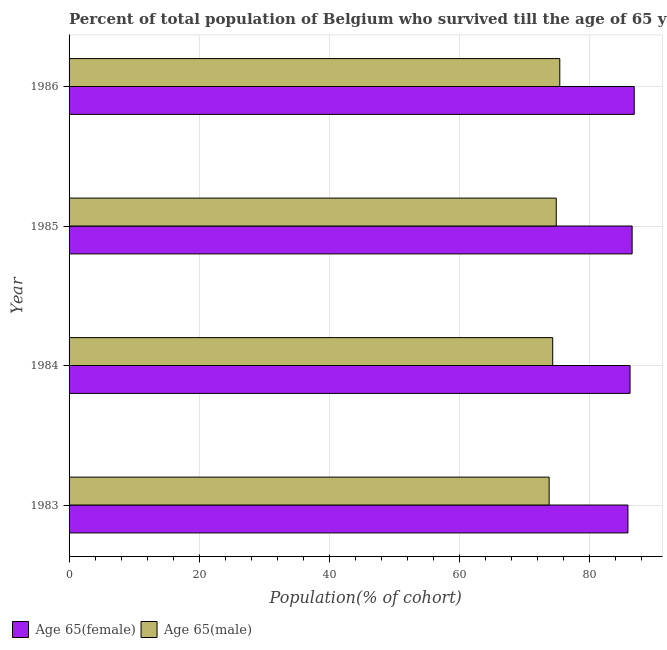How many different coloured bars are there?
Keep it short and to the point. 2. How many groups of bars are there?
Give a very brief answer. 4. Are the number of bars on each tick of the Y-axis equal?
Offer a very short reply. Yes. How many bars are there on the 2nd tick from the top?
Ensure brevity in your answer.  2. How many bars are there on the 3rd tick from the bottom?
Provide a succinct answer. 2. In how many cases, is the number of bars for a given year not equal to the number of legend labels?
Ensure brevity in your answer.  0. What is the percentage of female population who survived till age of 65 in 1986?
Your answer should be very brief. 86.83. Across all years, what is the maximum percentage of female population who survived till age of 65?
Keep it short and to the point. 86.83. Across all years, what is the minimum percentage of male population who survived till age of 65?
Make the answer very short. 73.76. In which year was the percentage of male population who survived till age of 65 maximum?
Your response must be concise. 1986. What is the total percentage of male population who survived till age of 65 in the graph?
Provide a short and direct response. 298.3. What is the difference between the percentage of female population who survived till age of 65 in 1984 and that in 1985?
Provide a short and direct response. -0.32. What is the difference between the percentage of female population who survived till age of 65 in 1984 and the percentage of male population who survived till age of 65 in 1983?
Your answer should be compact. 12.43. What is the average percentage of male population who survived till age of 65 per year?
Offer a terse response. 74.58. In the year 1984, what is the difference between the percentage of male population who survived till age of 65 and percentage of female population who survived till age of 65?
Your answer should be compact. -11.88. In how many years, is the percentage of female population who survived till age of 65 greater than 40 %?
Give a very brief answer. 4. What is the difference between the highest and the second highest percentage of female population who survived till age of 65?
Provide a succinct answer. 0.32. What is the difference between the highest and the lowest percentage of male population who survived till age of 65?
Ensure brevity in your answer.  1.64. Is the sum of the percentage of male population who survived till age of 65 in 1984 and 1985 greater than the maximum percentage of female population who survived till age of 65 across all years?
Give a very brief answer. Yes. What does the 2nd bar from the top in 1986 represents?
Give a very brief answer. Age 65(female). What does the 1st bar from the bottom in 1983 represents?
Offer a very short reply. Age 65(female). How many bars are there?
Give a very brief answer. 8. Are all the bars in the graph horizontal?
Offer a terse response. Yes. What is the difference between two consecutive major ticks on the X-axis?
Provide a succinct answer. 20. Does the graph contain any zero values?
Your answer should be very brief. No. Where does the legend appear in the graph?
Your response must be concise. Bottom left. What is the title of the graph?
Give a very brief answer. Percent of total population of Belgium who survived till the age of 65 years. Does "Girls" appear as one of the legend labels in the graph?
Provide a succinct answer. No. What is the label or title of the X-axis?
Your response must be concise. Population(% of cohort). What is the Population(% of cohort) in Age 65(female) in 1983?
Make the answer very short. 85.86. What is the Population(% of cohort) in Age 65(male) in 1983?
Provide a succinct answer. 73.76. What is the Population(% of cohort) in Age 65(female) in 1984?
Give a very brief answer. 86.19. What is the Population(% of cohort) in Age 65(male) in 1984?
Give a very brief answer. 74.3. What is the Population(% of cohort) in Age 65(female) in 1985?
Offer a terse response. 86.51. What is the Population(% of cohort) in Age 65(male) in 1985?
Give a very brief answer. 74.85. What is the Population(% of cohort) of Age 65(female) in 1986?
Provide a succinct answer. 86.83. What is the Population(% of cohort) of Age 65(male) in 1986?
Provide a short and direct response. 75.39. Across all years, what is the maximum Population(% of cohort) of Age 65(female)?
Your response must be concise. 86.83. Across all years, what is the maximum Population(% of cohort) of Age 65(male)?
Provide a short and direct response. 75.39. Across all years, what is the minimum Population(% of cohort) in Age 65(female)?
Provide a succinct answer. 85.86. Across all years, what is the minimum Population(% of cohort) in Age 65(male)?
Provide a succinct answer. 73.76. What is the total Population(% of cohort) in Age 65(female) in the graph?
Give a very brief answer. 345.39. What is the total Population(% of cohort) in Age 65(male) in the graph?
Provide a succinct answer. 298.3. What is the difference between the Population(% of cohort) of Age 65(female) in 1983 and that in 1984?
Make the answer very short. -0.32. What is the difference between the Population(% of cohort) of Age 65(male) in 1983 and that in 1984?
Your answer should be very brief. -0.55. What is the difference between the Population(% of cohort) of Age 65(female) in 1983 and that in 1985?
Your answer should be very brief. -0.64. What is the difference between the Population(% of cohort) in Age 65(male) in 1983 and that in 1985?
Offer a very short reply. -1.09. What is the difference between the Population(% of cohort) of Age 65(female) in 1983 and that in 1986?
Provide a succinct answer. -0.96. What is the difference between the Population(% of cohort) of Age 65(male) in 1983 and that in 1986?
Offer a very short reply. -1.64. What is the difference between the Population(% of cohort) of Age 65(female) in 1984 and that in 1985?
Keep it short and to the point. -0.32. What is the difference between the Population(% of cohort) of Age 65(male) in 1984 and that in 1985?
Make the answer very short. -0.55. What is the difference between the Population(% of cohort) in Age 65(female) in 1984 and that in 1986?
Your response must be concise. -0.64. What is the difference between the Population(% of cohort) in Age 65(male) in 1984 and that in 1986?
Your answer should be compact. -1.09. What is the difference between the Population(% of cohort) of Age 65(female) in 1985 and that in 1986?
Provide a succinct answer. -0.32. What is the difference between the Population(% of cohort) of Age 65(male) in 1985 and that in 1986?
Offer a very short reply. -0.55. What is the difference between the Population(% of cohort) in Age 65(female) in 1983 and the Population(% of cohort) in Age 65(male) in 1984?
Your answer should be compact. 11.56. What is the difference between the Population(% of cohort) of Age 65(female) in 1983 and the Population(% of cohort) of Age 65(male) in 1985?
Offer a very short reply. 11.02. What is the difference between the Population(% of cohort) in Age 65(female) in 1983 and the Population(% of cohort) in Age 65(male) in 1986?
Offer a very short reply. 10.47. What is the difference between the Population(% of cohort) in Age 65(female) in 1984 and the Population(% of cohort) in Age 65(male) in 1985?
Make the answer very short. 11.34. What is the difference between the Population(% of cohort) of Age 65(female) in 1984 and the Population(% of cohort) of Age 65(male) in 1986?
Ensure brevity in your answer.  10.79. What is the difference between the Population(% of cohort) in Age 65(female) in 1985 and the Population(% of cohort) in Age 65(male) in 1986?
Your answer should be compact. 11.11. What is the average Population(% of cohort) in Age 65(female) per year?
Keep it short and to the point. 86.35. What is the average Population(% of cohort) in Age 65(male) per year?
Make the answer very short. 74.58. In the year 1983, what is the difference between the Population(% of cohort) of Age 65(female) and Population(% of cohort) of Age 65(male)?
Your answer should be very brief. 12.11. In the year 1984, what is the difference between the Population(% of cohort) of Age 65(female) and Population(% of cohort) of Age 65(male)?
Your response must be concise. 11.88. In the year 1985, what is the difference between the Population(% of cohort) of Age 65(female) and Population(% of cohort) of Age 65(male)?
Your response must be concise. 11.66. In the year 1986, what is the difference between the Population(% of cohort) in Age 65(female) and Population(% of cohort) in Age 65(male)?
Your answer should be compact. 11.44. What is the ratio of the Population(% of cohort) of Age 65(female) in 1983 to that in 1984?
Offer a very short reply. 1. What is the ratio of the Population(% of cohort) in Age 65(male) in 1983 to that in 1984?
Provide a short and direct response. 0.99. What is the ratio of the Population(% of cohort) of Age 65(male) in 1983 to that in 1985?
Give a very brief answer. 0.99. What is the ratio of the Population(% of cohort) in Age 65(female) in 1983 to that in 1986?
Keep it short and to the point. 0.99. What is the ratio of the Population(% of cohort) in Age 65(male) in 1983 to that in 1986?
Keep it short and to the point. 0.98. What is the ratio of the Population(% of cohort) of Age 65(female) in 1984 to that in 1985?
Make the answer very short. 1. What is the ratio of the Population(% of cohort) in Age 65(male) in 1984 to that in 1985?
Offer a terse response. 0.99. What is the ratio of the Population(% of cohort) in Age 65(male) in 1984 to that in 1986?
Make the answer very short. 0.99. What is the difference between the highest and the second highest Population(% of cohort) in Age 65(female)?
Your answer should be compact. 0.32. What is the difference between the highest and the second highest Population(% of cohort) in Age 65(male)?
Your response must be concise. 0.55. What is the difference between the highest and the lowest Population(% of cohort) of Age 65(female)?
Offer a terse response. 0.96. What is the difference between the highest and the lowest Population(% of cohort) of Age 65(male)?
Your answer should be very brief. 1.64. 